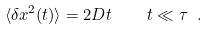<formula> <loc_0><loc_0><loc_500><loc_500>\langle \delta x ^ { 2 } ( t ) \rangle = 2 D t \quad t \ll \tau \ .</formula> 